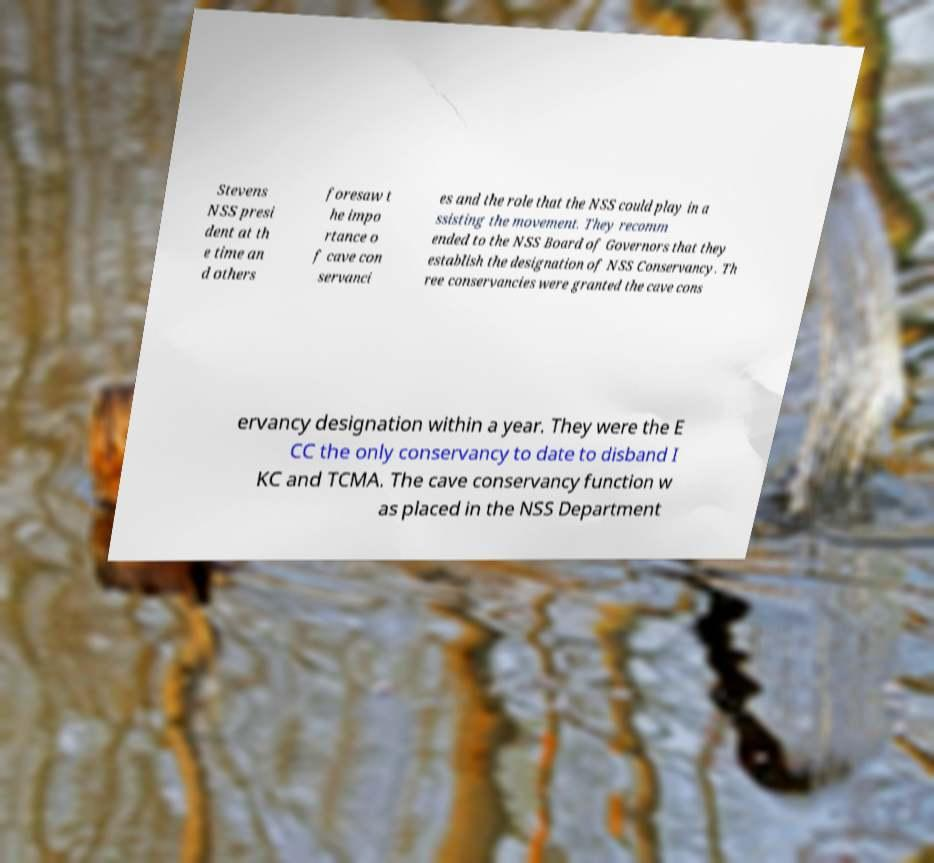Please identify and transcribe the text found in this image. Stevens NSS presi dent at th e time an d others foresaw t he impo rtance o f cave con servanci es and the role that the NSS could play in a ssisting the movement. They recomm ended to the NSS Board of Governors that they establish the designation of NSS Conservancy. Th ree conservancies were granted the cave cons ervancy designation within a year. They were the E CC the only conservancy to date to disband I KC and TCMA. The cave conservancy function w as placed in the NSS Department 